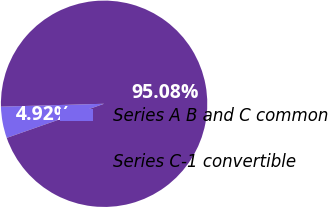Convert chart. <chart><loc_0><loc_0><loc_500><loc_500><pie_chart><fcel>Series A B and C common<fcel>Series C-1 convertible<nl><fcel>4.92%<fcel>95.08%<nl></chart> 